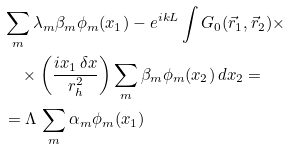<formula> <loc_0><loc_0><loc_500><loc_500>& \sum _ { m } \lambda _ { m } \beta _ { m } \phi _ { m } ( x _ { 1 } ) - e ^ { i k L } \int G _ { 0 } ( \vec { r } _ { 1 } , \vec { r } _ { 2 } ) \times \\ & \quad \times \left ( \frac { i x _ { 1 } \, \delta x } { r _ { h } ^ { 2 } } \right ) \sum _ { m } \beta _ { m } \phi _ { m } ( x _ { 2 } ) \, d x _ { 2 } = \\ & = \Lambda \, \sum _ { m } \alpha _ { m } \phi _ { m } ( x _ { 1 } ) \,</formula> 